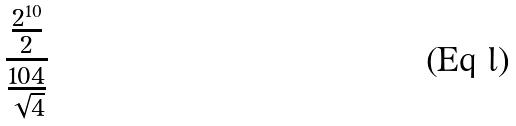Convert formula to latex. <formula><loc_0><loc_0><loc_500><loc_500>\frac { \frac { 2 ^ { 1 0 } } { 2 } } { \frac { 1 0 4 } { \sqrt { 4 } } }</formula> 